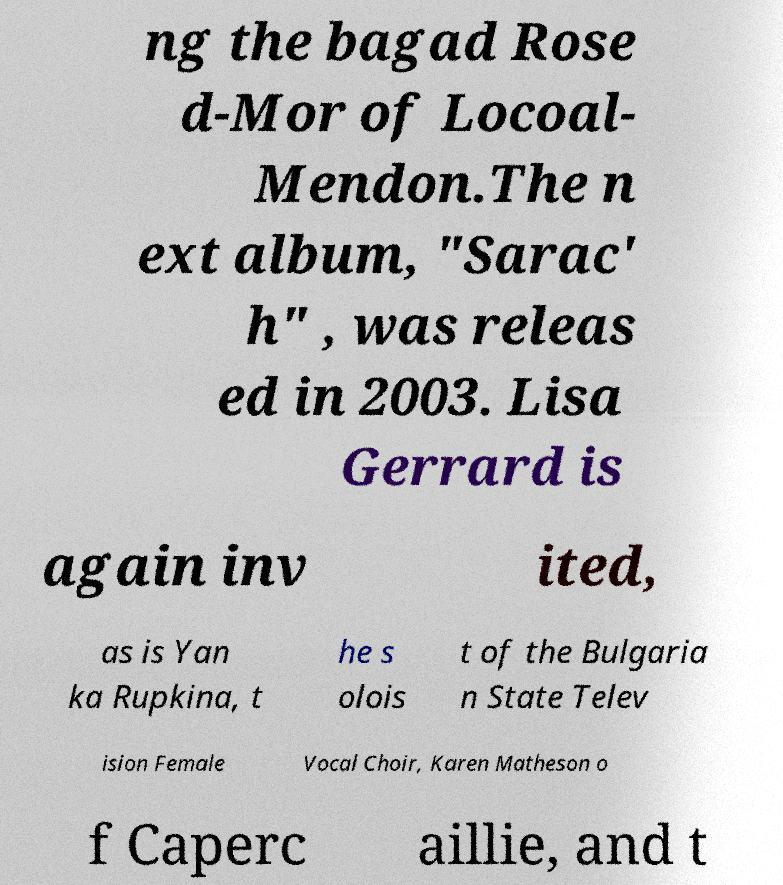Can you accurately transcribe the text from the provided image for me? ng the bagad Rose d-Mor of Locoal- Mendon.The n ext album, "Sarac' h" , was releas ed in 2003. Lisa Gerrard is again inv ited, as is Yan ka Rupkina, t he s olois t of the Bulgaria n State Telev ision Female Vocal Choir, Karen Matheson o f Caperc aillie, and t 